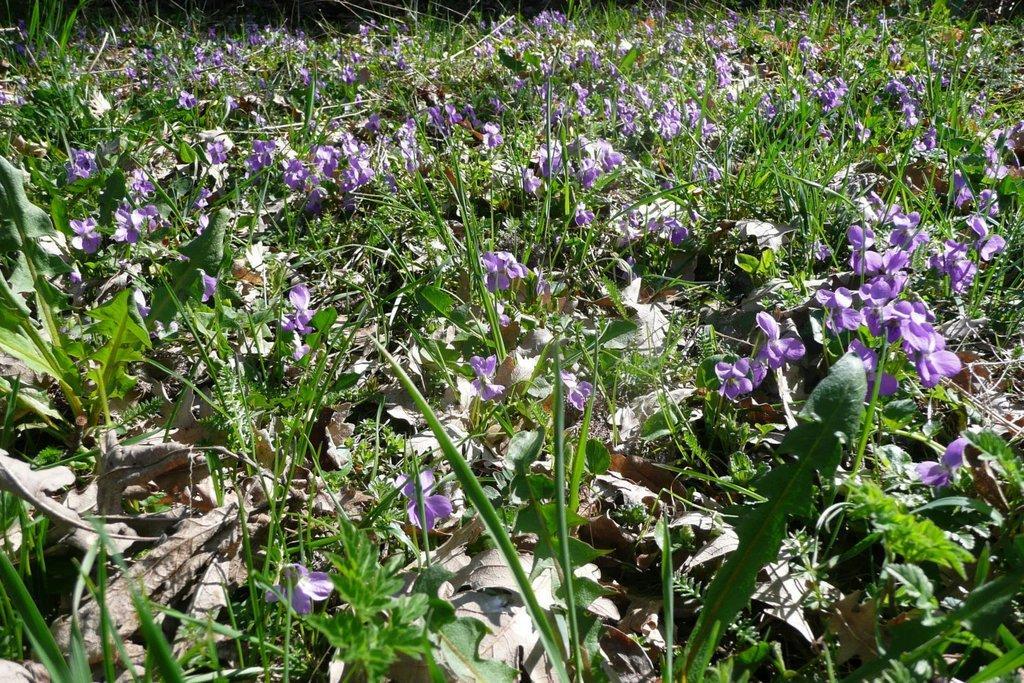Describe this image in one or two sentences. In the image we can see there are flowers on the plant and there are dry leaves on the ground. 